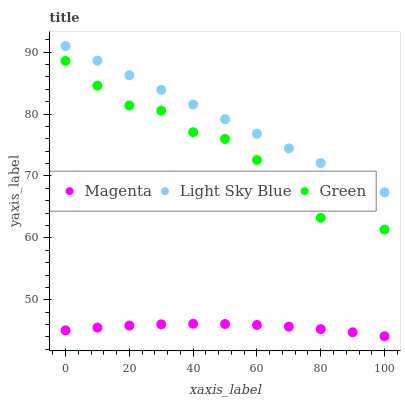Does Magenta have the minimum area under the curve?
Answer yes or no. Yes. Does Light Sky Blue have the maximum area under the curve?
Answer yes or no. Yes. Does Green have the minimum area under the curve?
Answer yes or no. No. Does Green have the maximum area under the curve?
Answer yes or no. No. Is Light Sky Blue the smoothest?
Answer yes or no. Yes. Is Green the roughest?
Answer yes or no. Yes. Is Green the smoothest?
Answer yes or no. No. Is Light Sky Blue the roughest?
Answer yes or no. No. Does Magenta have the lowest value?
Answer yes or no. Yes. Does Green have the lowest value?
Answer yes or no. No. Does Light Sky Blue have the highest value?
Answer yes or no. Yes. Does Green have the highest value?
Answer yes or no. No. Is Green less than Light Sky Blue?
Answer yes or no. Yes. Is Light Sky Blue greater than Green?
Answer yes or no. Yes. Does Green intersect Light Sky Blue?
Answer yes or no. No. 